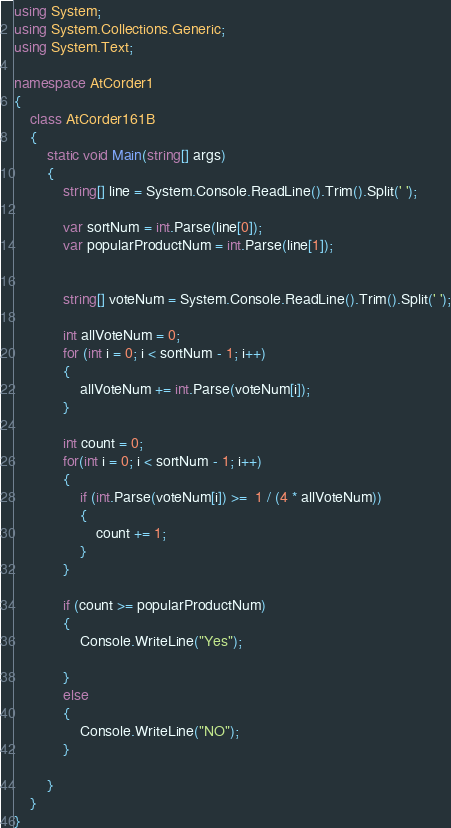<code> <loc_0><loc_0><loc_500><loc_500><_C#_>using System;
using System.Collections.Generic;
using System.Text;

namespace AtCorder1
{
    class AtCorder161B
    {
        static void Main(string[] args)
        {
            string[] line = System.Console.ReadLine().Trim().Split(' ');

            var sortNum = int.Parse(line[0]);
            var popularProductNum = int.Parse(line[1]);


            string[] voteNum = System.Console.ReadLine().Trim().Split(' ');

            int allVoteNum = 0;
            for (int i = 0; i < sortNum - 1; i++)
            {
                allVoteNum += int.Parse(voteNum[i]);
            }

            int count = 0;
            for(int i = 0; i < sortNum - 1; i++)
            {
                if (int.Parse(voteNum[i]) >=  1 / (4 * allVoteNum))
                {
                    count += 1;
                }
            }

            if (count >= popularProductNum)
            {
                Console.WriteLine("Yes");

            }
            else
            {
                Console.WriteLine("NO");
            }
      
        }
    }
}
</code> 